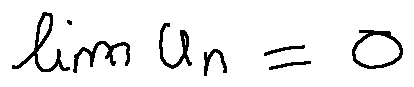Convert formula to latex. <formula><loc_0><loc_0><loc_500><loc_500>\lim u _ { n } = 0</formula> 